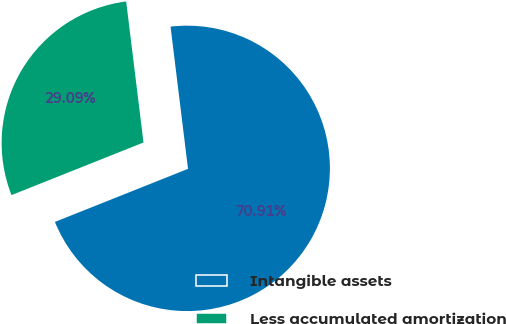Convert chart. <chart><loc_0><loc_0><loc_500><loc_500><pie_chart><fcel>Intangible assets<fcel>Less accumulated amortization<nl><fcel>70.91%<fcel>29.09%<nl></chart> 